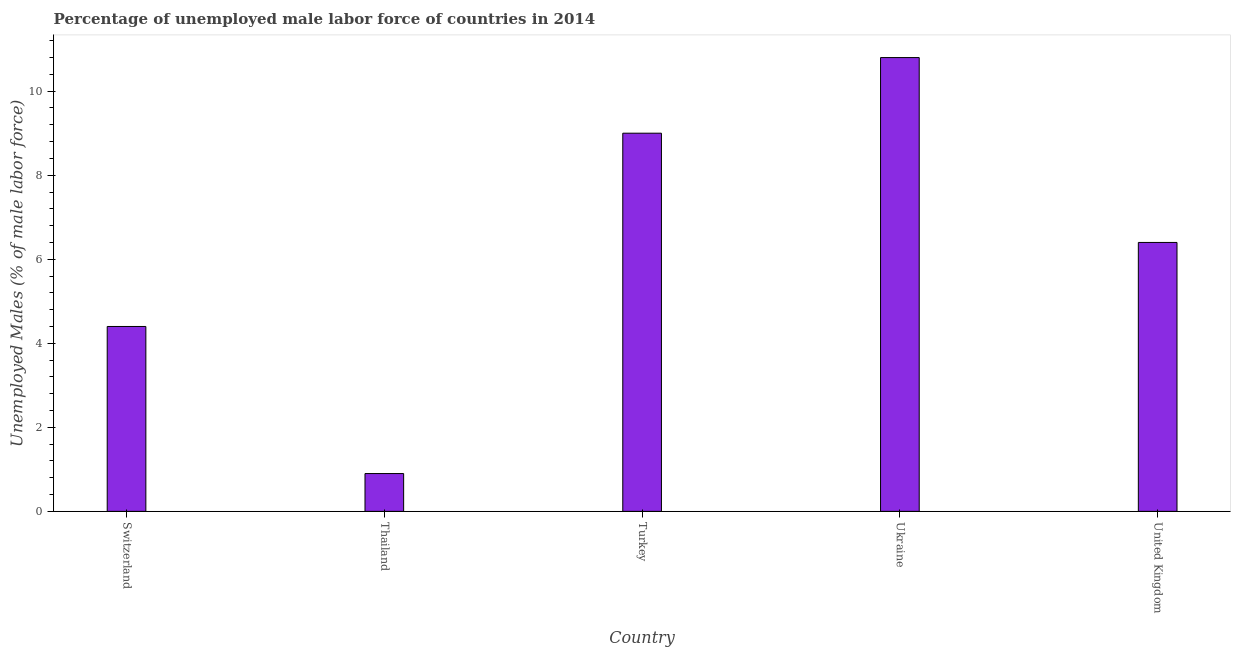What is the title of the graph?
Make the answer very short. Percentage of unemployed male labor force of countries in 2014. What is the label or title of the Y-axis?
Provide a succinct answer. Unemployed Males (% of male labor force). Across all countries, what is the maximum total unemployed male labour force?
Your answer should be very brief. 10.8. Across all countries, what is the minimum total unemployed male labour force?
Offer a very short reply. 0.9. In which country was the total unemployed male labour force maximum?
Your answer should be compact. Ukraine. In which country was the total unemployed male labour force minimum?
Provide a short and direct response. Thailand. What is the sum of the total unemployed male labour force?
Offer a terse response. 31.5. What is the difference between the total unemployed male labour force in Switzerland and United Kingdom?
Your response must be concise. -2. What is the average total unemployed male labour force per country?
Keep it short and to the point. 6.3. What is the median total unemployed male labour force?
Give a very brief answer. 6.4. In how many countries, is the total unemployed male labour force greater than 3.2 %?
Provide a short and direct response. 4. What is the ratio of the total unemployed male labour force in Switzerland to that in Turkey?
Your response must be concise. 0.49. Is the total unemployed male labour force in Switzerland less than that in Thailand?
Your response must be concise. No. Is the sum of the total unemployed male labour force in Switzerland and Thailand greater than the maximum total unemployed male labour force across all countries?
Offer a terse response. No. In how many countries, is the total unemployed male labour force greater than the average total unemployed male labour force taken over all countries?
Offer a very short reply. 3. What is the difference between two consecutive major ticks on the Y-axis?
Offer a very short reply. 2. Are the values on the major ticks of Y-axis written in scientific E-notation?
Provide a short and direct response. No. What is the Unemployed Males (% of male labor force) in Switzerland?
Provide a succinct answer. 4.4. What is the Unemployed Males (% of male labor force) in Thailand?
Provide a succinct answer. 0.9. What is the Unemployed Males (% of male labor force) in Ukraine?
Keep it short and to the point. 10.8. What is the Unemployed Males (% of male labor force) in United Kingdom?
Your answer should be compact. 6.4. What is the difference between the Unemployed Males (% of male labor force) in Thailand and United Kingdom?
Your answer should be very brief. -5.5. What is the ratio of the Unemployed Males (% of male labor force) in Switzerland to that in Thailand?
Your answer should be very brief. 4.89. What is the ratio of the Unemployed Males (% of male labor force) in Switzerland to that in Turkey?
Provide a short and direct response. 0.49. What is the ratio of the Unemployed Males (% of male labor force) in Switzerland to that in Ukraine?
Your answer should be compact. 0.41. What is the ratio of the Unemployed Males (% of male labor force) in Switzerland to that in United Kingdom?
Keep it short and to the point. 0.69. What is the ratio of the Unemployed Males (% of male labor force) in Thailand to that in Ukraine?
Your response must be concise. 0.08. What is the ratio of the Unemployed Males (% of male labor force) in Thailand to that in United Kingdom?
Offer a terse response. 0.14. What is the ratio of the Unemployed Males (% of male labor force) in Turkey to that in Ukraine?
Keep it short and to the point. 0.83. What is the ratio of the Unemployed Males (% of male labor force) in Turkey to that in United Kingdom?
Keep it short and to the point. 1.41. What is the ratio of the Unemployed Males (% of male labor force) in Ukraine to that in United Kingdom?
Your response must be concise. 1.69. 